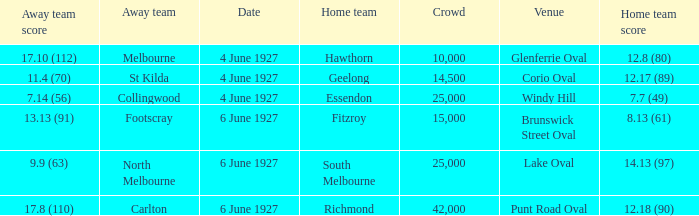How many people in the crowd with north melbourne as an away team? 25000.0. 